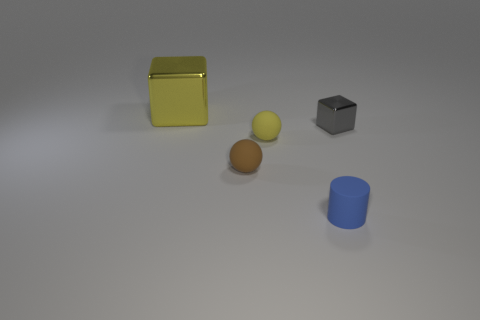Add 1 large yellow objects. How many objects exist? 6 Subtract all yellow spheres. How many spheres are left? 1 Subtract 0 cyan cylinders. How many objects are left? 5 Subtract all blocks. How many objects are left? 3 Subtract all yellow things. Subtract all small blue matte cylinders. How many objects are left? 2 Add 3 tiny metallic things. How many tiny metallic things are left? 4 Add 5 yellow objects. How many yellow objects exist? 7 